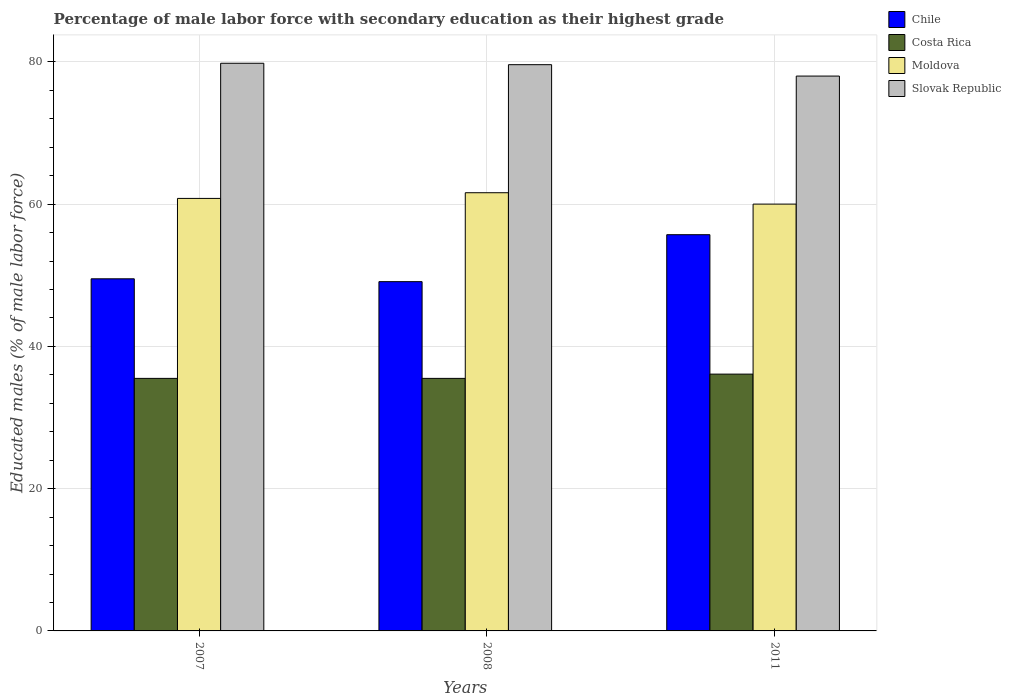Are the number of bars on each tick of the X-axis equal?
Offer a very short reply. Yes. How many bars are there on the 1st tick from the left?
Your answer should be compact. 4. How many bars are there on the 1st tick from the right?
Offer a very short reply. 4. What is the label of the 2nd group of bars from the left?
Your answer should be compact. 2008. In how many cases, is the number of bars for a given year not equal to the number of legend labels?
Ensure brevity in your answer.  0. Across all years, what is the maximum percentage of male labor force with secondary education in Chile?
Provide a succinct answer. 55.7. In which year was the percentage of male labor force with secondary education in Slovak Republic maximum?
Offer a terse response. 2007. In which year was the percentage of male labor force with secondary education in Slovak Republic minimum?
Make the answer very short. 2011. What is the total percentage of male labor force with secondary education in Slovak Republic in the graph?
Your answer should be very brief. 237.4. What is the difference between the percentage of male labor force with secondary education in Chile in 2008 and that in 2011?
Give a very brief answer. -6.6. What is the difference between the percentage of male labor force with secondary education in Slovak Republic in 2008 and the percentage of male labor force with secondary education in Chile in 2011?
Your answer should be very brief. 23.9. What is the average percentage of male labor force with secondary education in Chile per year?
Give a very brief answer. 51.43. In the year 2011, what is the difference between the percentage of male labor force with secondary education in Chile and percentage of male labor force with secondary education in Costa Rica?
Make the answer very short. 19.6. What is the ratio of the percentage of male labor force with secondary education in Chile in 2007 to that in 2011?
Make the answer very short. 0.89. What is the difference between the highest and the second highest percentage of male labor force with secondary education in Moldova?
Keep it short and to the point. 0.8. What is the difference between the highest and the lowest percentage of male labor force with secondary education in Chile?
Keep it short and to the point. 6.6. In how many years, is the percentage of male labor force with secondary education in Moldova greater than the average percentage of male labor force with secondary education in Moldova taken over all years?
Your response must be concise. 1. Is the sum of the percentage of male labor force with secondary education in Slovak Republic in 2007 and 2011 greater than the maximum percentage of male labor force with secondary education in Costa Rica across all years?
Your response must be concise. Yes. What does the 4th bar from the left in 2007 represents?
Give a very brief answer. Slovak Republic. Is it the case that in every year, the sum of the percentage of male labor force with secondary education in Moldova and percentage of male labor force with secondary education in Slovak Republic is greater than the percentage of male labor force with secondary education in Costa Rica?
Keep it short and to the point. Yes. Are all the bars in the graph horizontal?
Give a very brief answer. No. How many years are there in the graph?
Provide a succinct answer. 3. What is the difference between two consecutive major ticks on the Y-axis?
Your answer should be compact. 20. Does the graph contain any zero values?
Ensure brevity in your answer.  No. Does the graph contain grids?
Keep it short and to the point. Yes. How many legend labels are there?
Provide a succinct answer. 4. How are the legend labels stacked?
Keep it short and to the point. Vertical. What is the title of the graph?
Your answer should be compact. Percentage of male labor force with secondary education as their highest grade. Does "East Asia (all income levels)" appear as one of the legend labels in the graph?
Ensure brevity in your answer.  No. What is the label or title of the Y-axis?
Your answer should be very brief. Educated males (% of male labor force). What is the Educated males (% of male labor force) of Chile in 2007?
Provide a succinct answer. 49.5. What is the Educated males (% of male labor force) of Costa Rica in 2007?
Your answer should be compact. 35.5. What is the Educated males (% of male labor force) in Moldova in 2007?
Offer a very short reply. 60.8. What is the Educated males (% of male labor force) in Slovak Republic in 2007?
Your answer should be compact. 79.8. What is the Educated males (% of male labor force) in Chile in 2008?
Your answer should be compact. 49.1. What is the Educated males (% of male labor force) of Costa Rica in 2008?
Your answer should be very brief. 35.5. What is the Educated males (% of male labor force) in Moldova in 2008?
Your answer should be compact. 61.6. What is the Educated males (% of male labor force) of Slovak Republic in 2008?
Provide a succinct answer. 79.6. What is the Educated males (% of male labor force) in Chile in 2011?
Give a very brief answer. 55.7. What is the Educated males (% of male labor force) in Costa Rica in 2011?
Offer a very short reply. 36.1. What is the Educated males (% of male labor force) in Slovak Republic in 2011?
Provide a short and direct response. 78. Across all years, what is the maximum Educated males (% of male labor force) in Chile?
Your answer should be very brief. 55.7. Across all years, what is the maximum Educated males (% of male labor force) of Costa Rica?
Your answer should be very brief. 36.1. Across all years, what is the maximum Educated males (% of male labor force) of Moldova?
Ensure brevity in your answer.  61.6. Across all years, what is the maximum Educated males (% of male labor force) of Slovak Republic?
Offer a very short reply. 79.8. Across all years, what is the minimum Educated males (% of male labor force) in Chile?
Keep it short and to the point. 49.1. Across all years, what is the minimum Educated males (% of male labor force) of Costa Rica?
Give a very brief answer. 35.5. What is the total Educated males (% of male labor force) in Chile in the graph?
Your response must be concise. 154.3. What is the total Educated males (% of male labor force) in Costa Rica in the graph?
Your response must be concise. 107.1. What is the total Educated males (% of male labor force) of Moldova in the graph?
Your answer should be very brief. 182.4. What is the total Educated males (% of male labor force) of Slovak Republic in the graph?
Provide a short and direct response. 237.4. What is the difference between the Educated males (% of male labor force) in Chile in 2007 and that in 2008?
Ensure brevity in your answer.  0.4. What is the difference between the Educated males (% of male labor force) in Costa Rica in 2007 and that in 2011?
Your answer should be compact. -0.6. What is the difference between the Educated males (% of male labor force) in Moldova in 2007 and that in 2011?
Provide a succinct answer. 0.8. What is the difference between the Educated males (% of male labor force) in Slovak Republic in 2007 and that in 2011?
Your answer should be very brief. 1.8. What is the difference between the Educated males (% of male labor force) of Costa Rica in 2008 and that in 2011?
Offer a terse response. -0.6. What is the difference between the Educated males (% of male labor force) in Slovak Republic in 2008 and that in 2011?
Make the answer very short. 1.6. What is the difference between the Educated males (% of male labor force) of Chile in 2007 and the Educated males (% of male labor force) of Moldova in 2008?
Ensure brevity in your answer.  -12.1. What is the difference between the Educated males (% of male labor force) in Chile in 2007 and the Educated males (% of male labor force) in Slovak Republic in 2008?
Your answer should be very brief. -30.1. What is the difference between the Educated males (% of male labor force) in Costa Rica in 2007 and the Educated males (% of male labor force) in Moldova in 2008?
Provide a short and direct response. -26.1. What is the difference between the Educated males (% of male labor force) in Costa Rica in 2007 and the Educated males (% of male labor force) in Slovak Republic in 2008?
Your answer should be very brief. -44.1. What is the difference between the Educated males (% of male labor force) of Moldova in 2007 and the Educated males (% of male labor force) of Slovak Republic in 2008?
Your response must be concise. -18.8. What is the difference between the Educated males (% of male labor force) of Chile in 2007 and the Educated males (% of male labor force) of Moldova in 2011?
Your response must be concise. -10.5. What is the difference between the Educated males (% of male labor force) in Chile in 2007 and the Educated males (% of male labor force) in Slovak Republic in 2011?
Your answer should be very brief. -28.5. What is the difference between the Educated males (% of male labor force) of Costa Rica in 2007 and the Educated males (% of male labor force) of Moldova in 2011?
Ensure brevity in your answer.  -24.5. What is the difference between the Educated males (% of male labor force) of Costa Rica in 2007 and the Educated males (% of male labor force) of Slovak Republic in 2011?
Ensure brevity in your answer.  -42.5. What is the difference between the Educated males (% of male labor force) of Moldova in 2007 and the Educated males (% of male labor force) of Slovak Republic in 2011?
Provide a short and direct response. -17.2. What is the difference between the Educated males (% of male labor force) of Chile in 2008 and the Educated males (% of male labor force) of Costa Rica in 2011?
Keep it short and to the point. 13. What is the difference between the Educated males (% of male labor force) in Chile in 2008 and the Educated males (% of male labor force) in Slovak Republic in 2011?
Make the answer very short. -28.9. What is the difference between the Educated males (% of male labor force) in Costa Rica in 2008 and the Educated males (% of male labor force) in Moldova in 2011?
Give a very brief answer. -24.5. What is the difference between the Educated males (% of male labor force) in Costa Rica in 2008 and the Educated males (% of male labor force) in Slovak Republic in 2011?
Provide a short and direct response. -42.5. What is the difference between the Educated males (% of male labor force) of Moldova in 2008 and the Educated males (% of male labor force) of Slovak Republic in 2011?
Provide a succinct answer. -16.4. What is the average Educated males (% of male labor force) in Chile per year?
Your answer should be very brief. 51.43. What is the average Educated males (% of male labor force) in Costa Rica per year?
Make the answer very short. 35.7. What is the average Educated males (% of male labor force) in Moldova per year?
Your answer should be compact. 60.8. What is the average Educated males (% of male labor force) of Slovak Republic per year?
Keep it short and to the point. 79.13. In the year 2007, what is the difference between the Educated males (% of male labor force) of Chile and Educated males (% of male labor force) of Moldova?
Offer a terse response. -11.3. In the year 2007, what is the difference between the Educated males (% of male labor force) of Chile and Educated males (% of male labor force) of Slovak Republic?
Offer a terse response. -30.3. In the year 2007, what is the difference between the Educated males (% of male labor force) in Costa Rica and Educated males (% of male labor force) in Moldova?
Provide a short and direct response. -25.3. In the year 2007, what is the difference between the Educated males (% of male labor force) of Costa Rica and Educated males (% of male labor force) of Slovak Republic?
Make the answer very short. -44.3. In the year 2007, what is the difference between the Educated males (% of male labor force) in Moldova and Educated males (% of male labor force) in Slovak Republic?
Provide a short and direct response. -19. In the year 2008, what is the difference between the Educated males (% of male labor force) of Chile and Educated males (% of male labor force) of Costa Rica?
Your response must be concise. 13.6. In the year 2008, what is the difference between the Educated males (% of male labor force) in Chile and Educated males (% of male labor force) in Moldova?
Offer a very short reply. -12.5. In the year 2008, what is the difference between the Educated males (% of male labor force) in Chile and Educated males (% of male labor force) in Slovak Republic?
Make the answer very short. -30.5. In the year 2008, what is the difference between the Educated males (% of male labor force) in Costa Rica and Educated males (% of male labor force) in Moldova?
Ensure brevity in your answer.  -26.1. In the year 2008, what is the difference between the Educated males (% of male labor force) in Costa Rica and Educated males (% of male labor force) in Slovak Republic?
Make the answer very short. -44.1. In the year 2011, what is the difference between the Educated males (% of male labor force) in Chile and Educated males (% of male labor force) in Costa Rica?
Provide a succinct answer. 19.6. In the year 2011, what is the difference between the Educated males (% of male labor force) in Chile and Educated males (% of male labor force) in Moldova?
Your response must be concise. -4.3. In the year 2011, what is the difference between the Educated males (% of male labor force) in Chile and Educated males (% of male labor force) in Slovak Republic?
Keep it short and to the point. -22.3. In the year 2011, what is the difference between the Educated males (% of male labor force) in Costa Rica and Educated males (% of male labor force) in Moldova?
Ensure brevity in your answer.  -23.9. In the year 2011, what is the difference between the Educated males (% of male labor force) of Costa Rica and Educated males (% of male labor force) of Slovak Republic?
Ensure brevity in your answer.  -41.9. In the year 2011, what is the difference between the Educated males (% of male labor force) of Moldova and Educated males (% of male labor force) of Slovak Republic?
Your answer should be very brief. -18. What is the ratio of the Educated males (% of male labor force) in Costa Rica in 2007 to that in 2008?
Your answer should be compact. 1. What is the ratio of the Educated males (% of male labor force) in Moldova in 2007 to that in 2008?
Ensure brevity in your answer.  0.99. What is the ratio of the Educated males (% of male labor force) in Slovak Republic in 2007 to that in 2008?
Make the answer very short. 1. What is the ratio of the Educated males (% of male labor force) of Chile in 2007 to that in 2011?
Keep it short and to the point. 0.89. What is the ratio of the Educated males (% of male labor force) of Costa Rica in 2007 to that in 2011?
Offer a terse response. 0.98. What is the ratio of the Educated males (% of male labor force) in Moldova in 2007 to that in 2011?
Your answer should be very brief. 1.01. What is the ratio of the Educated males (% of male labor force) of Slovak Republic in 2007 to that in 2011?
Keep it short and to the point. 1.02. What is the ratio of the Educated males (% of male labor force) in Chile in 2008 to that in 2011?
Keep it short and to the point. 0.88. What is the ratio of the Educated males (% of male labor force) of Costa Rica in 2008 to that in 2011?
Your answer should be very brief. 0.98. What is the ratio of the Educated males (% of male labor force) in Moldova in 2008 to that in 2011?
Give a very brief answer. 1.03. What is the ratio of the Educated males (% of male labor force) of Slovak Republic in 2008 to that in 2011?
Offer a terse response. 1.02. What is the difference between the highest and the second highest Educated males (% of male labor force) in Moldova?
Provide a short and direct response. 0.8. What is the difference between the highest and the lowest Educated males (% of male labor force) in Slovak Republic?
Keep it short and to the point. 1.8. 